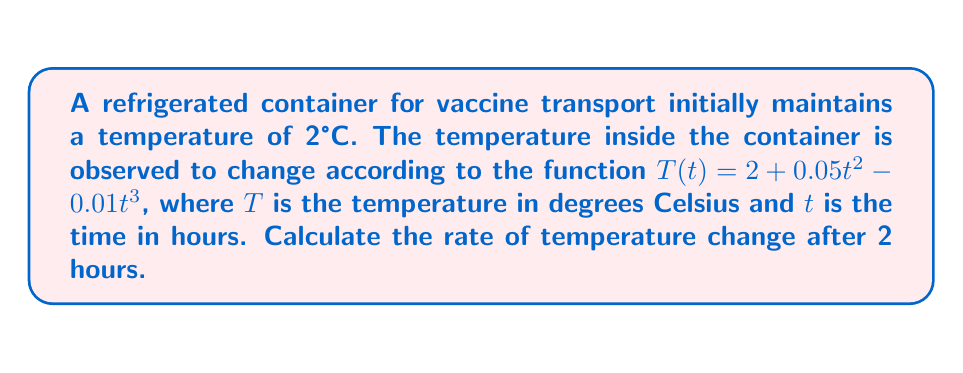Provide a solution to this math problem. To solve this problem, we need to find the derivative of the temperature function $T(t)$ with respect to time and then evaluate it at $t = 2$ hours.

1. Given temperature function:
   $T(t) = 2 + 0.05t^2 - 0.01t^3$

2. Find the derivative $\frac{dT}{dt}$ using the power rule:
   $$\frac{dT}{dt} = 0 + 0.05 \cdot 2t^1 - 0.01 \cdot 3t^2$$
   $$\frac{dT}{dt} = 0.1t - 0.03t^2$$

3. Evaluate the derivative at $t = 2$ hours:
   $$\frac{dT}{dt}\bigg|_{t=2} = 0.1(2) - 0.03(2^2)$$
   $$\frac{dT}{dt}\bigg|_{t=2} = 0.2 - 0.03(4)$$
   $$\frac{dT}{dt}\bigg|_{t=2} = 0.2 - 0.12$$
   $$\frac{dT}{dt}\bigg|_{t=2} = 0.08$$

The rate of temperature change after 2 hours is 0.08°C per hour.
Answer: 0.08°C/hour 